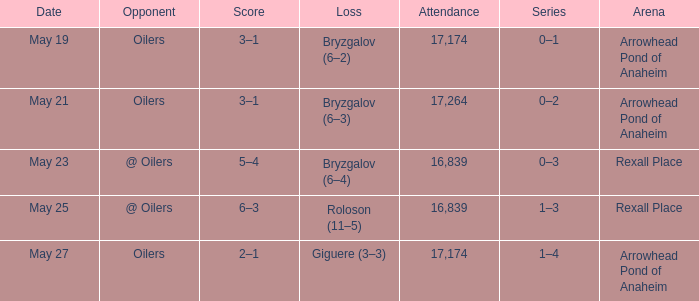What was the number of attendees on may 21? 17264.0. 